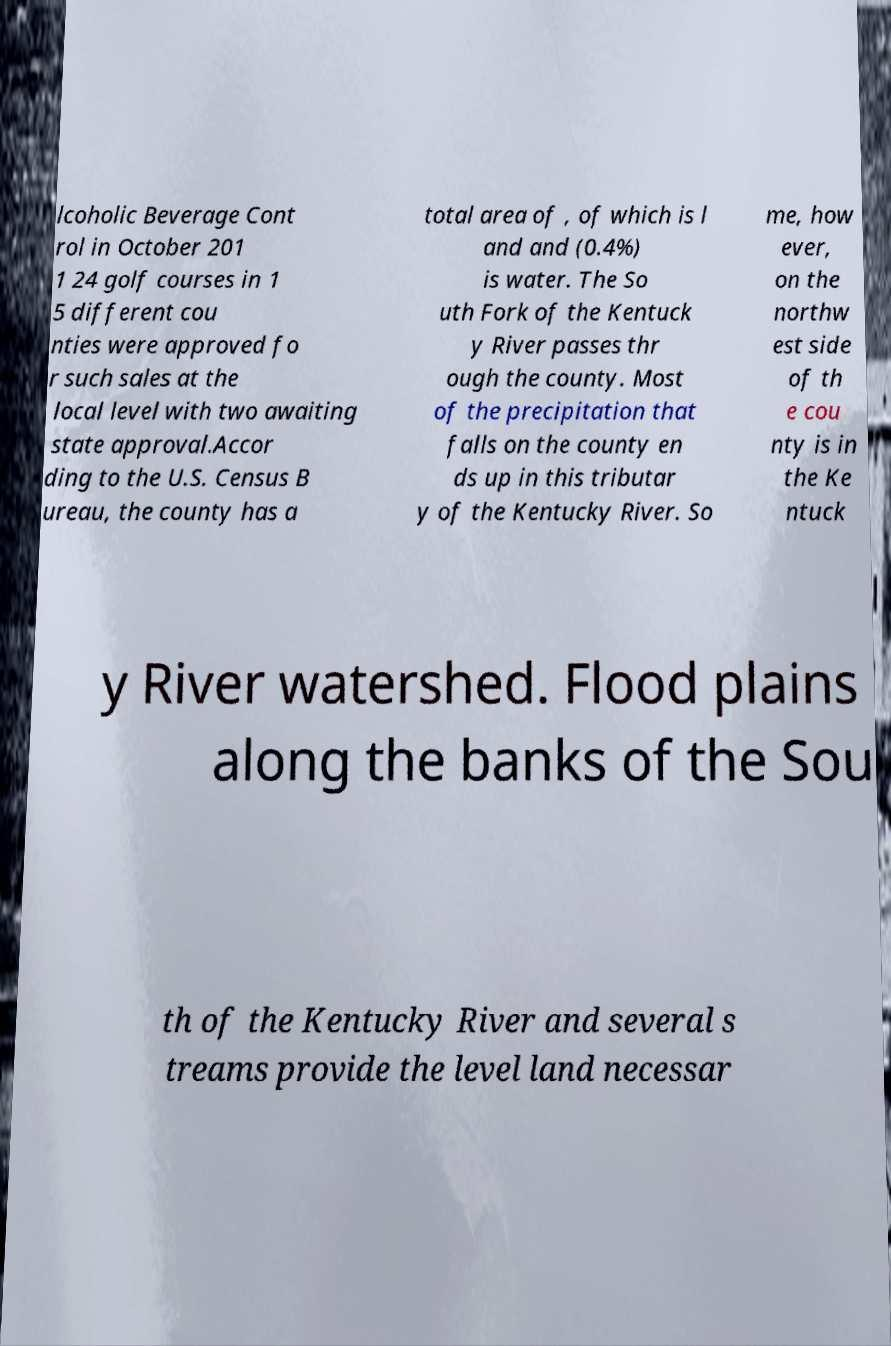Can you accurately transcribe the text from the provided image for me? lcoholic Beverage Cont rol in October 201 1 24 golf courses in 1 5 different cou nties were approved fo r such sales at the local level with two awaiting state approval.Accor ding to the U.S. Census B ureau, the county has a total area of , of which is l and and (0.4%) is water. The So uth Fork of the Kentuck y River passes thr ough the county. Most of the precipitation that falls on the county en ds up in this tributar y of the Kentucky River. So me, how ever, on the northw est side of th e cou nty is in the Ke ntuck y River watershed. Flood plains along the banks of the Sou th of the Kentucky River and several s treams provide the level land necessar 